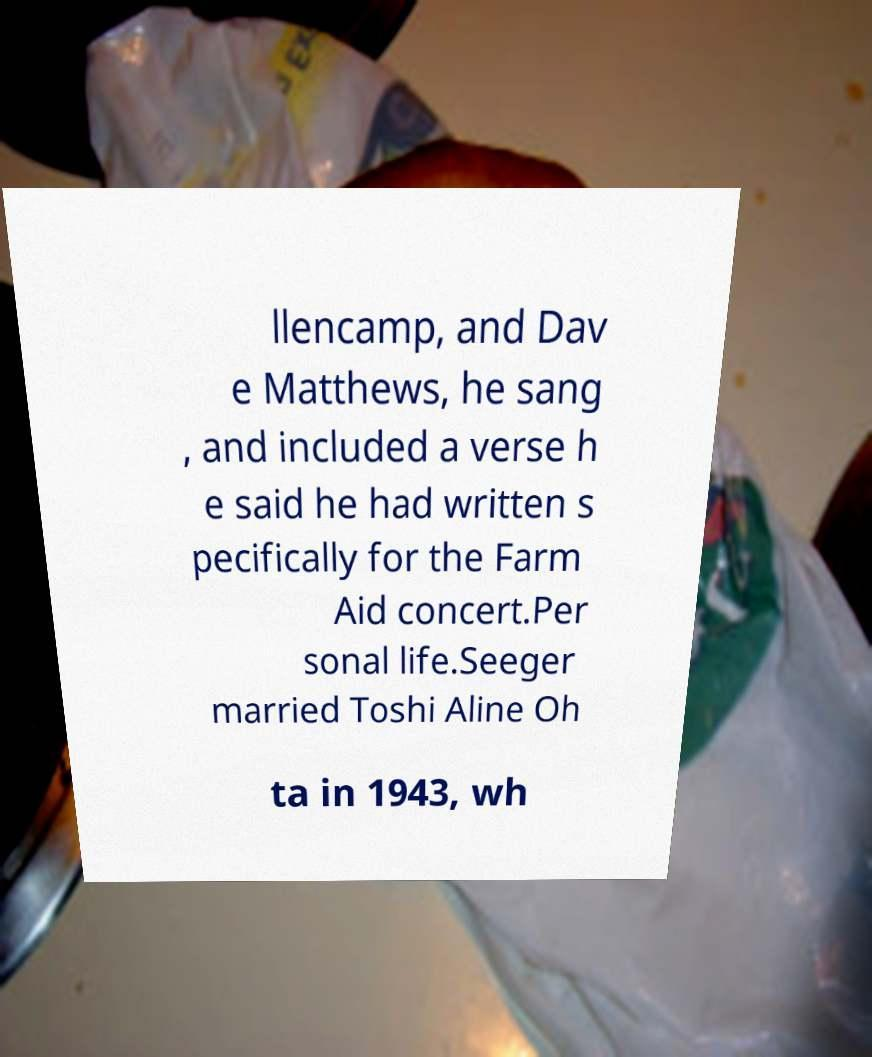Can you read and provide the text displayed in the image?This photo seems to have some interesting text. Can you extract and type it out for me? llencamp, and Dav e Matthews, he sang , and included a verse h e said he had written s pecifically for the Farm Aid concert.Per sonal life.Seeger married Toshi Aline Oh ta in 1943, wh 